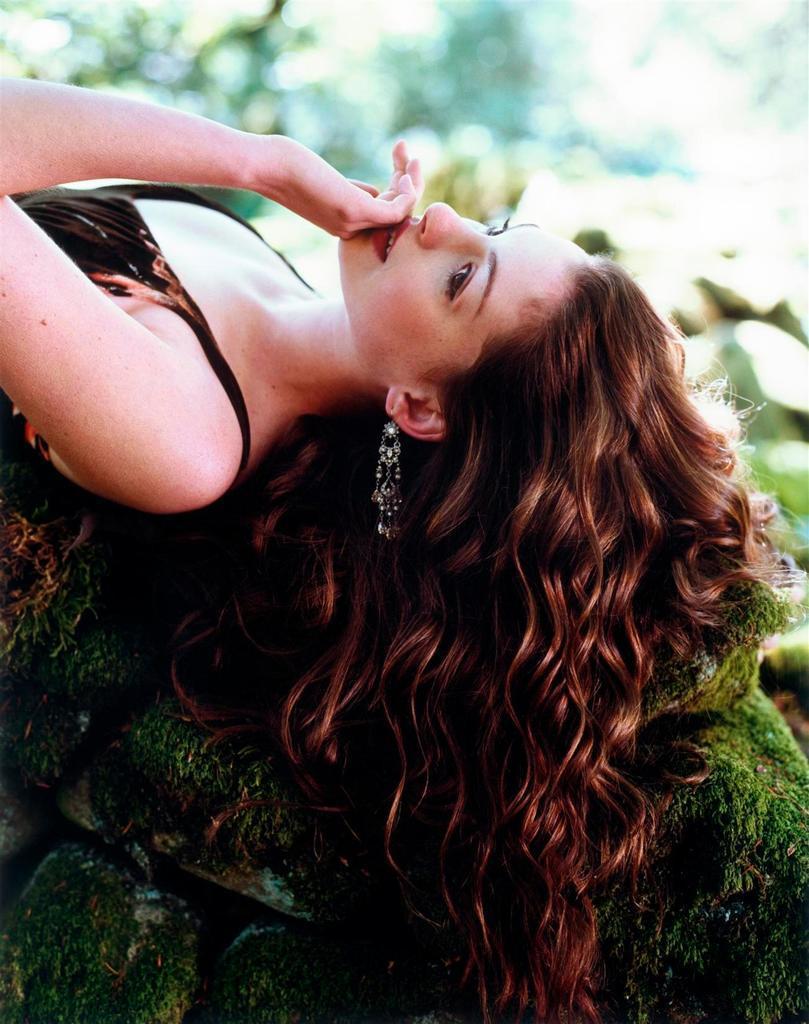In one or two sentences, can you explain what this image depicts? There is a lady lying on the rocks. On the rocks there is algae. In the background it is blurred. 